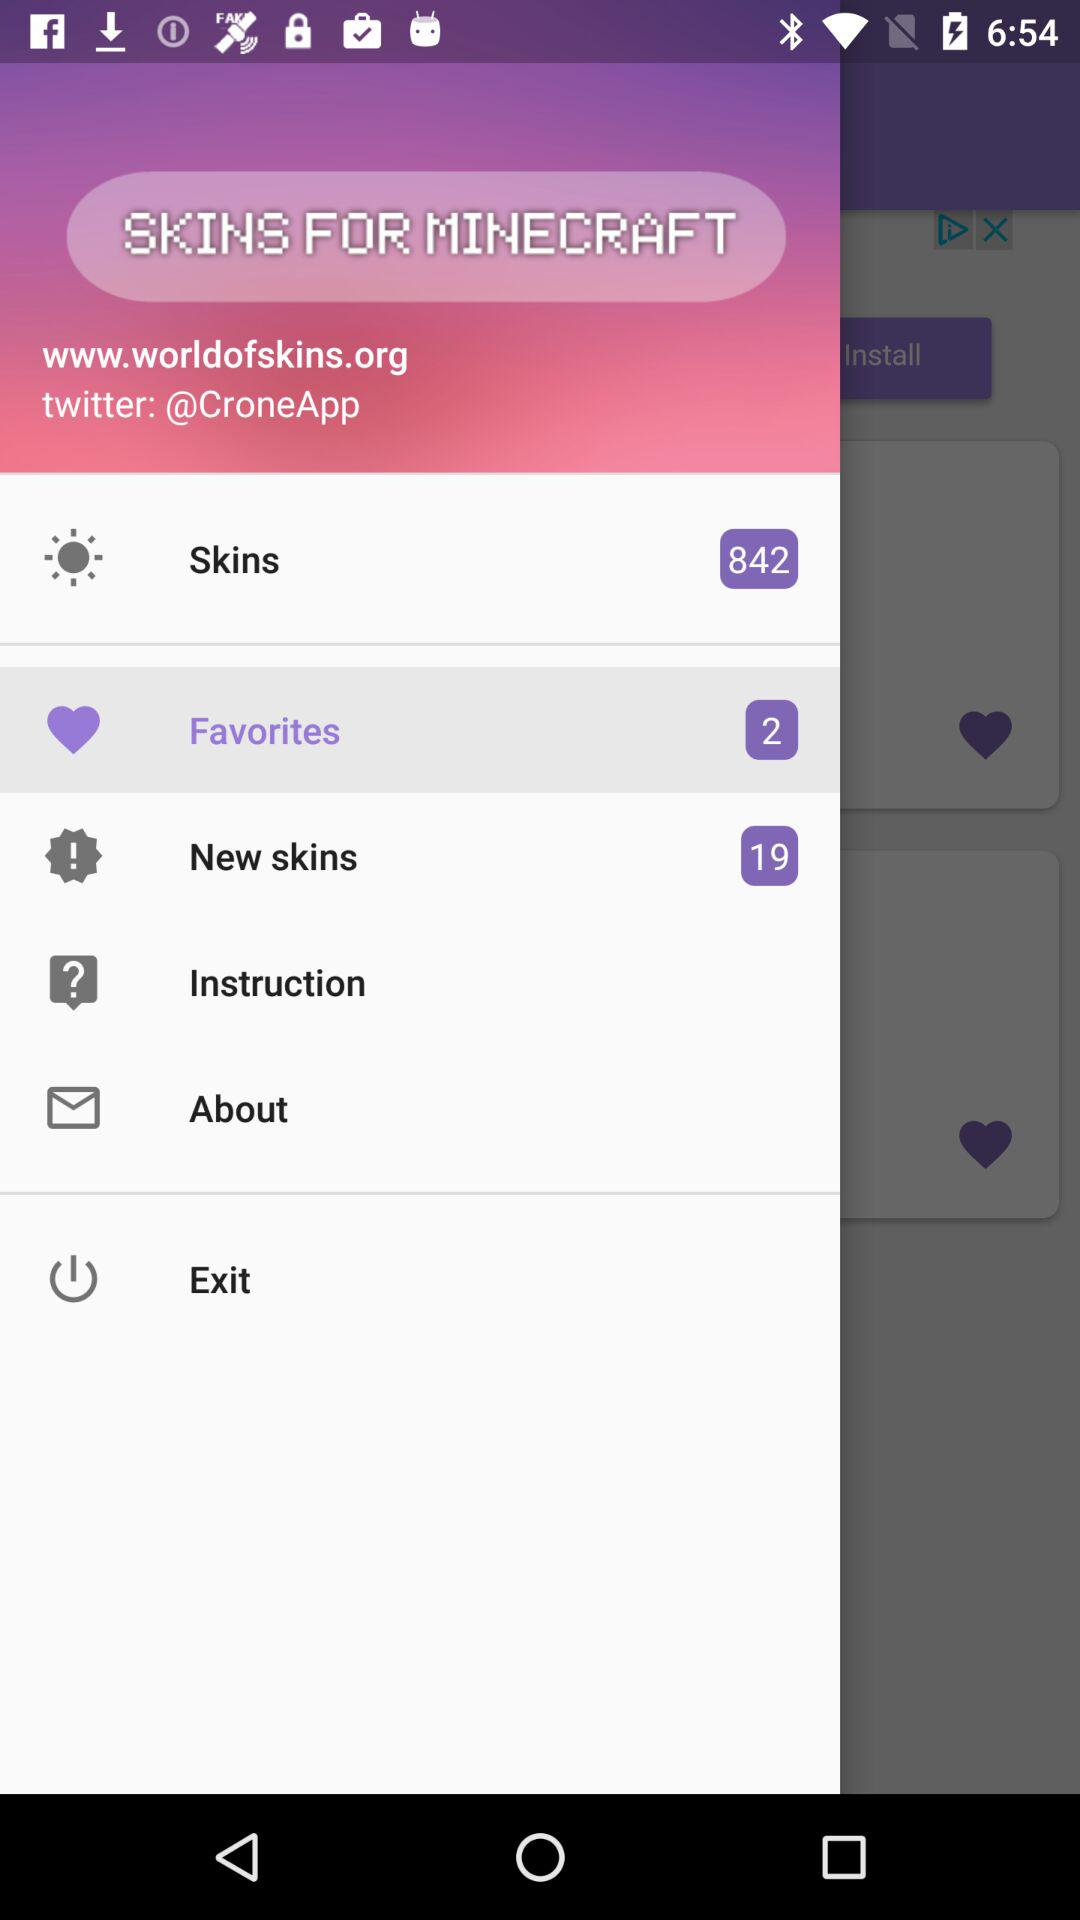What is the application name? The application name is "SKINS FOR MINECRAFT". 